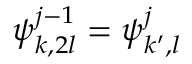Convert formula to latex. <formula><loc_0><loc_0><loc_500><loc_500>\psi _ { k , 2 l } ^ { j - 1 } = \psi _ { k ^ { \prime } , l } ^ { j }</formula> 